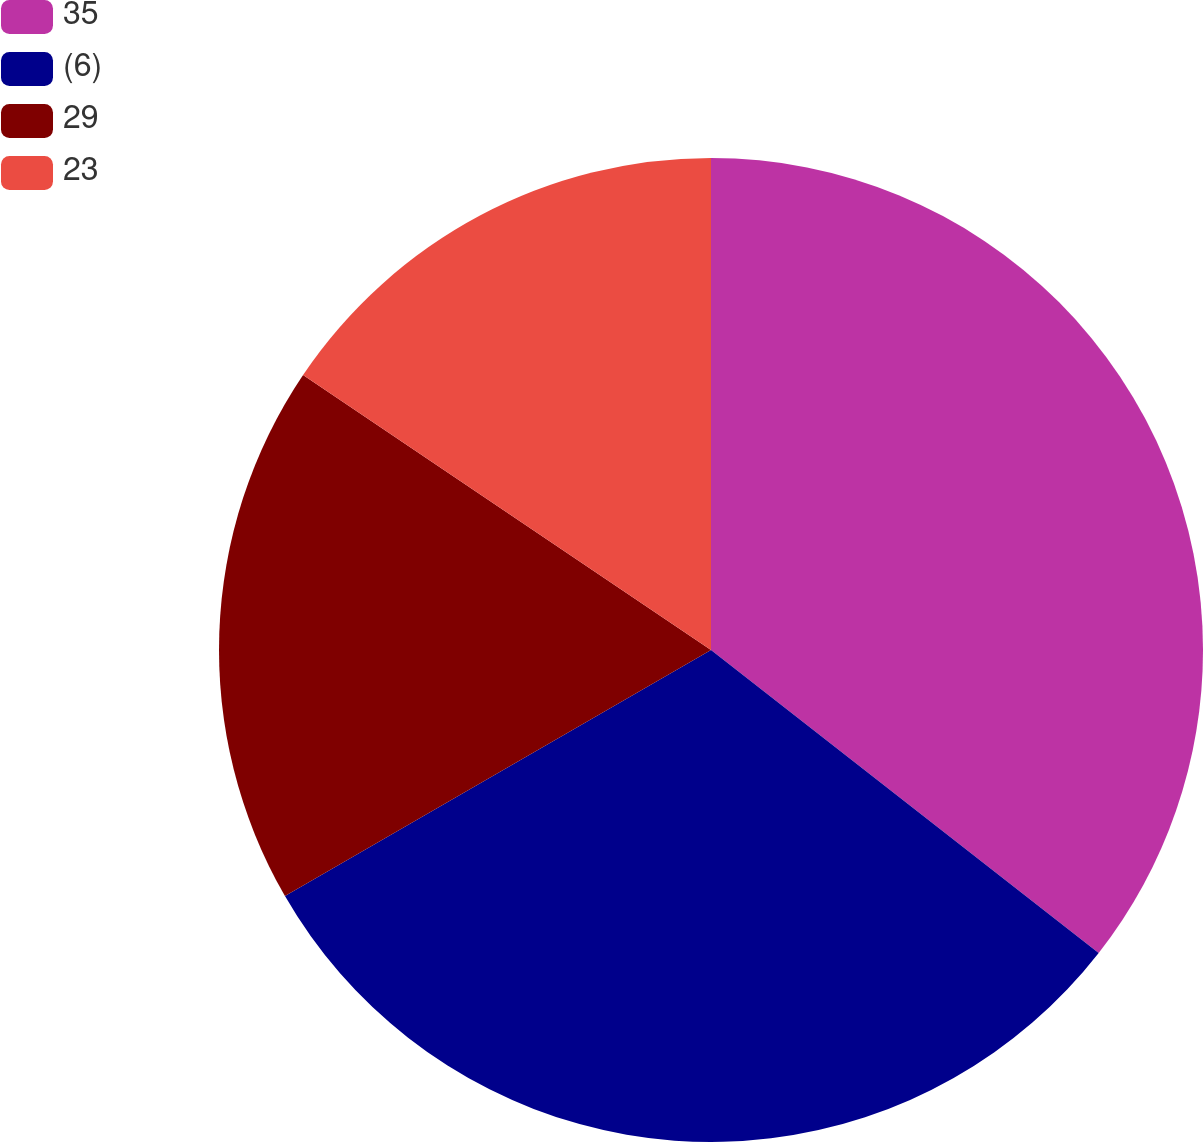Convert chart. <chart><loc_0><loc_0><loc_500><loc_500><pie_chart><fcel>35<fcel>(6)<fcel>29<fcel>23<nl><fcel>35.56%<fcel>31.11%<fcel>17.78%<fcel>15.56%<nl></chart> 